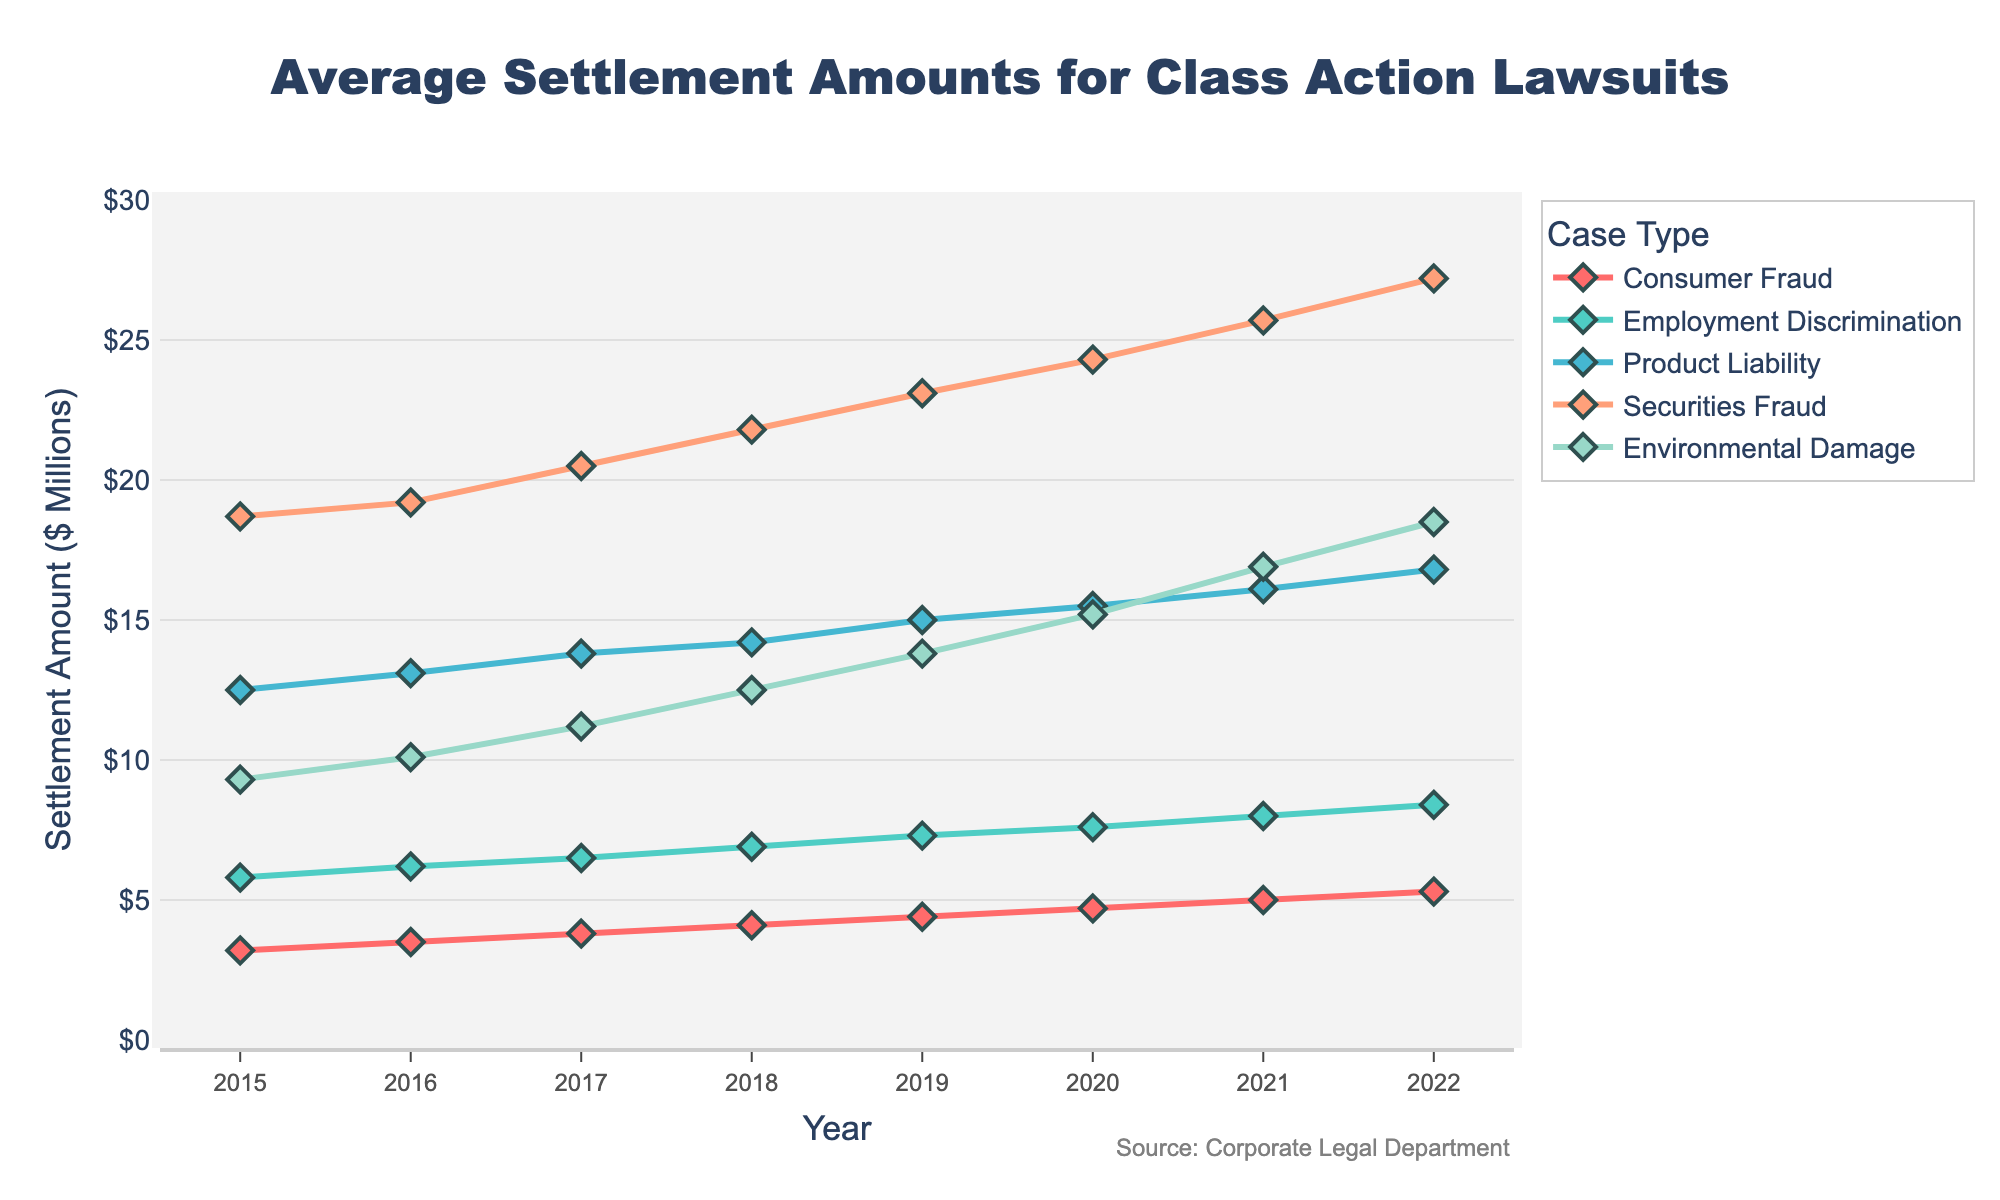What was the trend in average settlement amounts for Consumer Fraud cases from 2015 to 2022? To determine the trend, observe the data points for Consumer Fraud from 2015 to 2022. The average settlement amounts increase from 3.2 million in 2015 to 5.3 million in 2022, indicating a consistent upward trend.
Answer: Upward trend In which year did Product Liability cases see the highest settlement amount, and what was that amount? Look at the plotted line for Product Liability cases and find the highest point. The highest settlement amount for Product Liability cases was in 2022, with an amount of 16.8 million.
Answer: 2022, 16.8 million How did the average settlement amount for Securities Fraud cases in 2018 compare to Environmental Damage cases in the same year? Locate the data points for 2018 on the lines representing Securities Fraud and Environmental Damage. Securities Fraud cases have an amount of 21.8 million, while Environmental Damage cases have an amount of 12.5 million. Thus, Securities Fraud settlements were higher.
Answer: Securities Fraud settlements were higher Calculate the total average settlement amount for all case types in the year 2017. Sum the average settlement amounts for all case types in 2017: Consumer Fraud (3.8) + Employment Discrimination (6.5) + Product Liability (13.8) + Securities Fraud (20.5) + Environmental Damage (11.2) = 55.8 million.
Answer: 55.8 million Which case type had the least average settlement amount in 2016 and by how much was it lower than the highest settlement amount in the same year? Identify the lowest and highest settlement amounts for 2016. Consumer Fraud had the least at 3.5 million, and Securities Fraud had the most at 19.2 million. The difference is 19.2 - 3.5 = 15.7 million.
Answer: Consumer Fraud, 15.7 million Between which consecutive years did Employment Discrimination see the biggest increase in average settlement amounts? Compare the year-to-year increases for Employment Discrimination. The biggest increase is between 2021 (8.0) and 2022 (8.4), with an increase of 0.4 million.
Answer: 2021 to 2022 What is the average settlement amount for Environmental Damage cases over the period from 2015 to 2022? Sum the settlement amounts for Environmental Damage from 2015 to 2022 and divide by the number of years (8): (9.3 + 10.1 + 11.2 + 12.5 + 13.8 + 15.2 + 16.9 + 18.5) / 8 = 13.44 million.
Answer: 13.44 million Which case type consistently showed the highest settlement amounts throughout the period from 2015 to 2022? By observing the plotted lines, Securities Fraud is always above the other lines, indicating it had the highest settlement amounts consistently.
Answer: Securities Fraud 